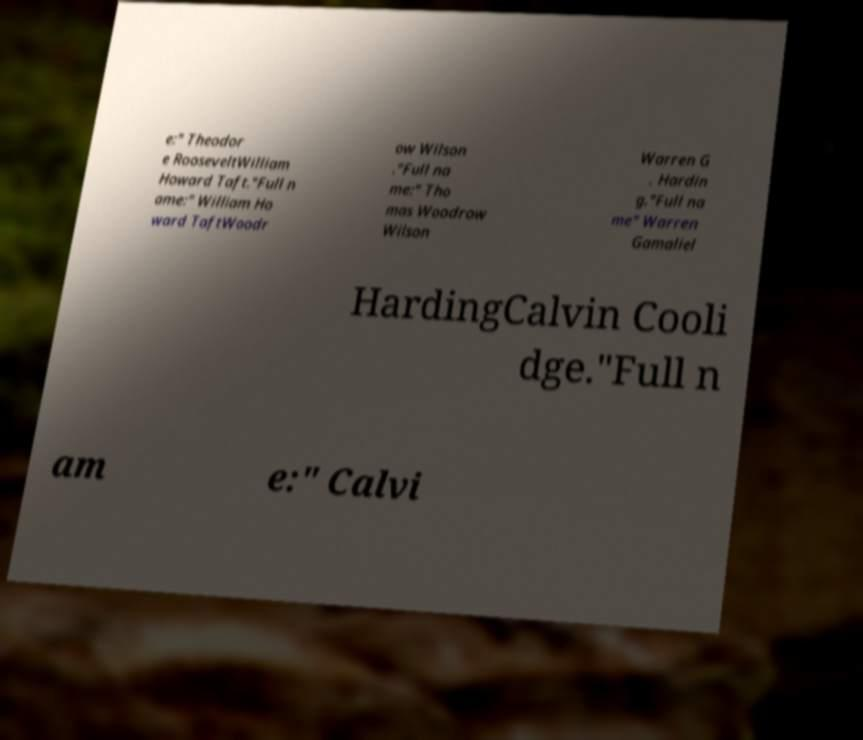For documentation purposes, I need the text within this image transcribed. Could you provide that? e:" Theodor e RooseveltWilliam Howard Taft."Full n ame:" William Ho ward TaftWoodr ow Wilson ."Full na me:" Tho mas Woodrow Wilson Warren G . Hardin g."Full na me" Warren Gamaliel HardingCalvin Cooli dge."Full n am e:" Calvi 